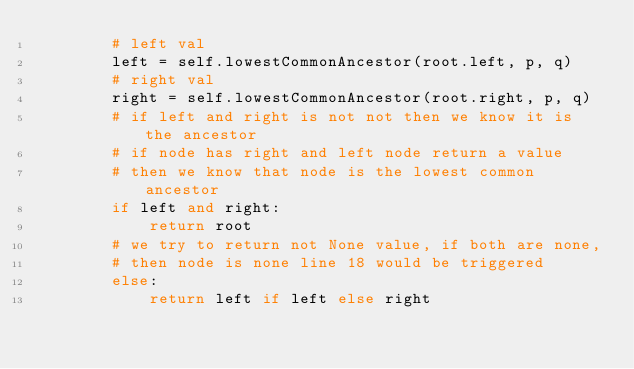Convert code to text. <code><loc_0><loc_0><loc_500><loc_500><_Python_>        # left val
        left = self.lowestCommonAncestor(root.left, p, q)
        # right val
        right = self.lowestCommonAncestor(root.right, p, q)
        # if left and right is not not then we know it is the ancestor
        # if node has right and left node return a value
        # then we know that node is the lowest common ancestor
        if left and right:
            return root
        # we try to return not None value, if both are none,
        # then node is none line 18 would be triggered
        else:
            return left if left else right
</code> 